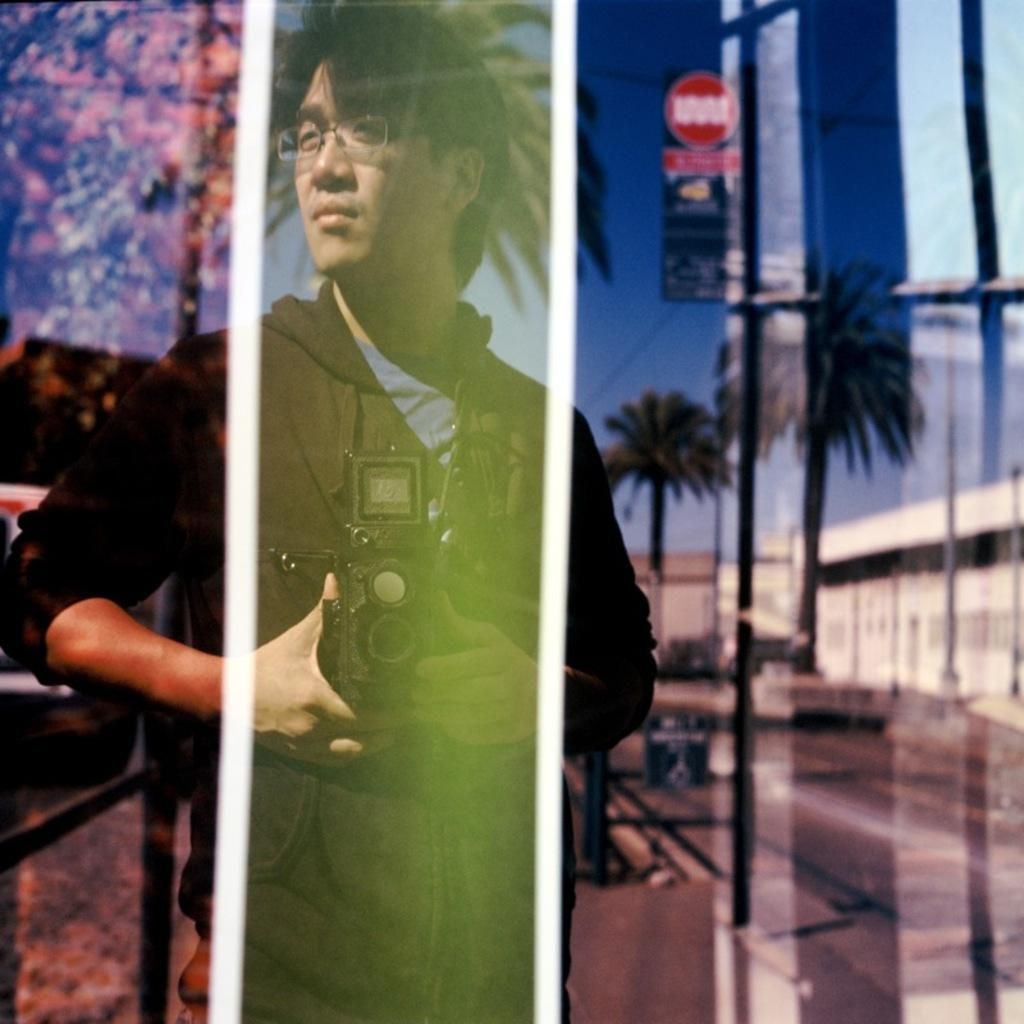Who is present in the image? There is a man in the image. What is the man wearing? The man is wearing spectacles. What is the man holding in the image? The man is holding a camera. What can be seen in the mirror reflection in the image? Trees and sign boards are visible in the mirror reflection. What grade did the man receive in the image? There is no indication of a grade or any educational context in the image. --- Facts: 1. There is a car in the image. 2. The car is red. 3. The car has four wheels. 4. There is a road in the image. 5. The road is paved. Absurd Topics: dance, ocean, bird Conversation: What is the main subject of the image? The main subject of the image is a car. What color is the car? The car is red. How many wheels does the car have? The car has four wheels. What is the surface of the road in the image? The road is paved. Reasoning: Let's think step by step in order to produce the conversation. We start by identifying the main subject in the image, which is the car. Then, we describe the car's color and the number of wheels it has. Finally, we focus on the road in the image and mention its surface, which is paved. Absurd Question/Answer: Can you see any birds dancing in the ocean in the image? There is no ocean or birds present in the image; it features a red car on a paved road. 